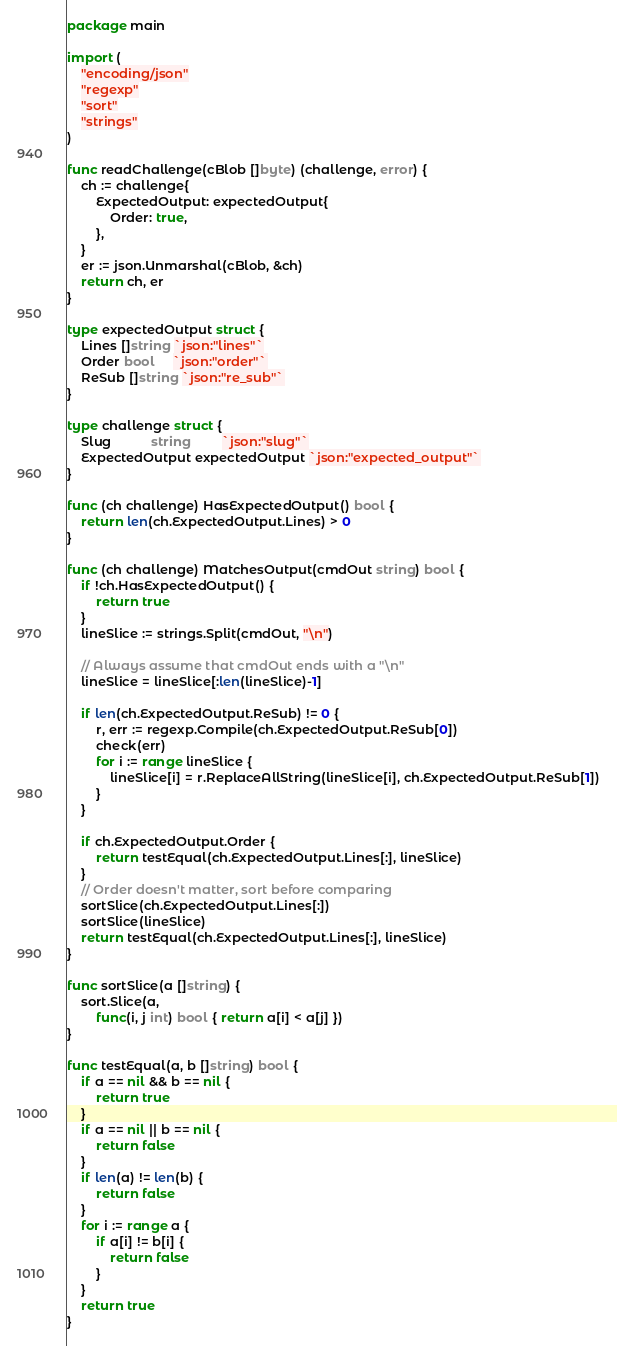<code> <loc_0><loc_0><loc_500><loc_500><_Go_>package main

import (
	"encoding/json"
	"regexp"
	"sort"
	"strings"
)

func readChallenge(cBlob []byte) (challenge, error) {
	ch := challenge{
		ExpectedOutput: expectedOutput{
			Order: true,
		},
	}
	er := json.Unmarshal(cBlob, &ch)
	return ch, er
}

type expectedOutput struct {
	Lines []string `json:"lines"`
	Order bool     `json:"order"`
	ReSub []string `json:"re_sub"`
}

type challenge struct {
	Slug           string         `json:"slug"`
	ExpectedOutput expectedOutput `json:"expected_output"`
}

func (ch challenge) HasExpectedOutput() bool {
	return len(ch.ExpectedOutput.Lines) > 0
}

func (ch challenge) MatchesOutput(cmdOut string) bool {
	if !ch.HasExpectedOutput() {
		return true
	}
	lineSlice := strings.Split(cmdOut, "\n")

	// Always assume that cmdOut ends with a "\n"
	lineSlice = lineSlice[:len(lineSlice)-1]

	if len(ch.ExpectedOutput.ReSub) != 0 {
		r, err := regexp.Compile(ch.ExpectedOutput.ReSub[0])
		check(err)
		for i := range lineSlice {
			lineSlice[i] = r.ReplaceAllString(lineSlice[i], ch.ExpectedOutput.ReSub[1])
		}
	}

	if ch.ExpectedOutput.Order {
		return testEqual(ch.ExpectedOutput.Lines[:], lineSlice)
	}
	// Order doesn't matter, sort before comparing
	sortSlice(ch.ExpectedOutput.Lines[:])
	sortSlice(lineSlice)
	return testEqual(ch.ExpectedOutput.Lines[:], lineSlice)
}

func sortSlice(a []string) {
	sort.Slice(a,
		func(i, j int) bool { return a[i] < a[j] })
}

func testEqual(a, b []string) bool {
	if a == nil && b == nil {
		return true
	}
	if a == nil || b == nil {
		return false
	}
	if len(a) != len(b) {
		return false
	}
	for i := range a {
		if a[i] != b[i] {
			return false
		}
	}
	return true
}
</code> 